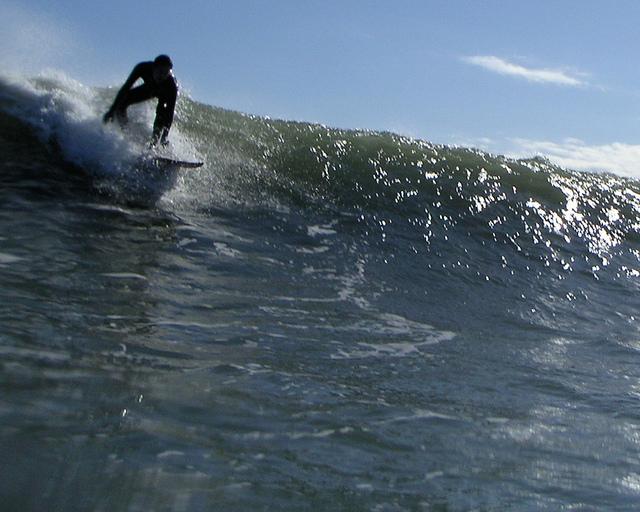Is it Winter?
Answer briefly. No. Is this person wearing a helmet?
Be succinct. No. Is the man surfing?
Write a very short answer. Yes. Where is the man?
Answer briefly. Ocean. Is this winter?
Be succinct. No. What is the season?
Be succinct. Summer. Is this the ocean?
Short answer required. Yes. Is this person surfing?
Answer briefly. Yes. Is the water most likely warm or cold?
Answer briefly. Warm. Is there snow?
Keep it brief. No. Is it a cold day?
Write a very short answer. No. Was this picture taken at the ocean?
Short answer required. Yes. Is someone in the picture?
Be succinct. Yes. Is it sunny?
Answer briefly. Yes. What type of environment do the animals live in?
Quick response, please. Ocean. 